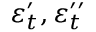<formula> <loc_0><loc_0><loc_500><loc_500>\boldsymbol \varepsilon _ { t } ^ { \prime } , \boldsymbol \varepsilon _ { t } ^ { \prime \prime }</formula> 